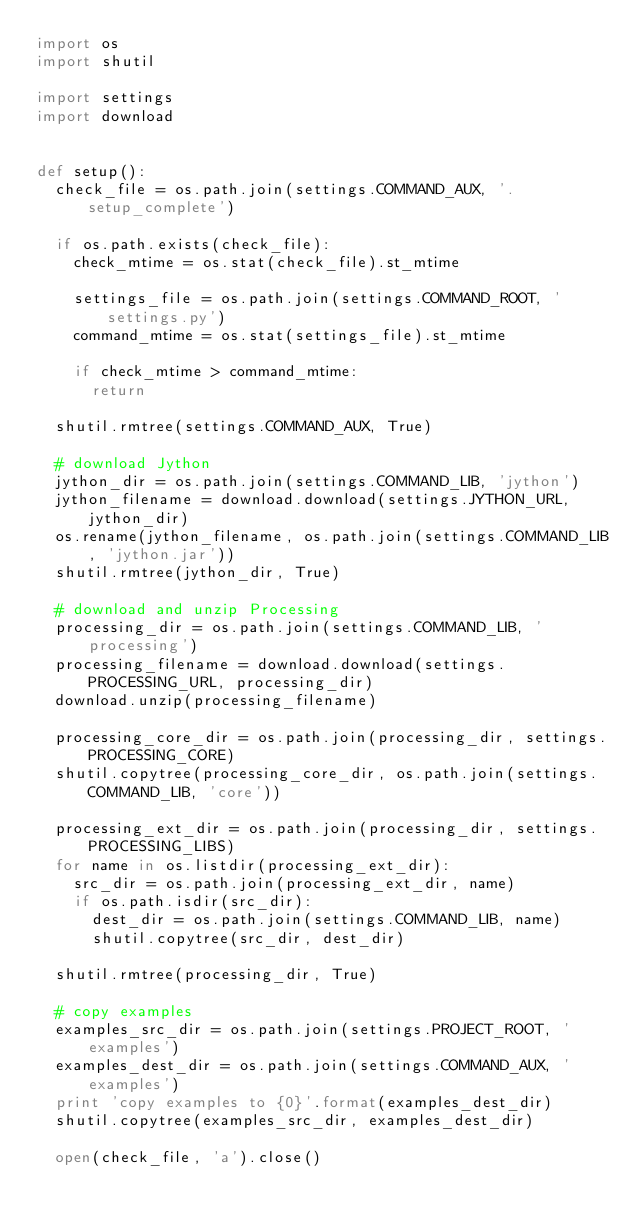Convert code to text. <code><loc_0><loc_0><loc_500><loc_500><_Python_>import os
import shutil

import settings
import download


def setup():
  check_file = os.path.join(settings.COMMAND_AUX, '.setup_complete')

  if os.path.exists(check_file):
    check_mtime = os.stat(check_file).st_mtime

    settings_file = os.path.join(settings.COMMAND_ROOT, 'settings.py')
    command_mtime = os.stat(settings_file).st_mtime

    if check_mtime > command_mtime:
      return

  shutil.rmtree(settings.COMMAND_AUX, True)

  # download Jython
  jython_dir = os.path.join(settings.COMMAND_LIB, 'jython')
  jython_filename = download.download(settings.JYTHON_URL, jython_dir)
  os.rename(jython_filename, os.path.join(settings.COMMAND_LIB, 'jython.jar'))
  shutil.rmtree(jython_dir, True)

  # download and unzip Processing
  processing_dir = os.path.join(settings.COMMAND_LIB, 'processing')
  processing_filename = download.download(settings.PROCESSING_URL, processing_dir)
  download.unzip(processing_filename)

  processing_core_dir = os.path.join(processing_dir, settings.PROCESSING_CORE)
  shutil.copytree(processing_core_dir, os.path.join(settings.COMMAND_LIB, 'core'))

  processing_ext_dir = os.path.join(processing_dir, settings.PROCESSING_LIBS)
  for name in os.listdir(processing_ext_dir):
    src_dir = os.path.join(processing_ext_dir, name)
    if os.path.isdir(src_dir):
      dest_dir = os.path.join(settings.COMMAND_LIB, name)
      shutil.copytree(src_dir, dest_dir)

  shutil.rmtree(processing_dir, True)

  # copy examples
  examples_src_dir = os.path.join(settings.PROJECT_ROOT, 'examples')
  examples_dest_dir = os.path.join(settings.COMMAND_AUX, 'examples')
  print 'copy examples to {0}'.format(examples_dest_dir)
  shutil.copytree(examples_src_dir, examples_dest_dir)

  open(check_file, 'a').close()
</code> 